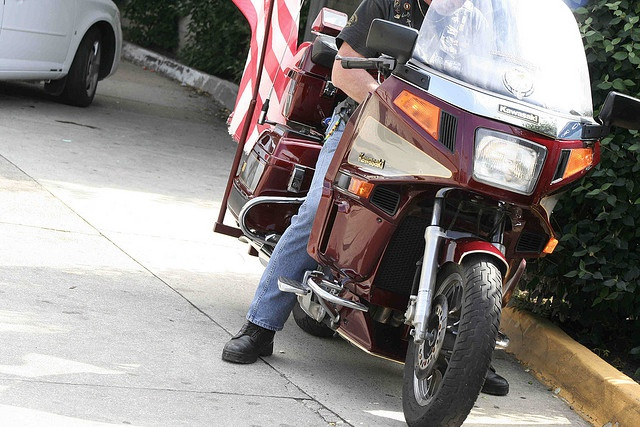Describe the objects in this image and their specific colors. I can see motorcycle in lavender, black, white, gray, and maroon tones, people in lavender, black, gray, and tan tones, and car in lavender, darkgray, black, and gray tones in this image. 